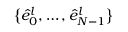Convert formula to latex. <formula><loc_0><loc_0><loc_500><loc_500>\left \{ \hat { e } _ { 0 } ^ { l } , \dots , \hat { e } _ { N - 1 } ^ { l } \right \}</formula> 